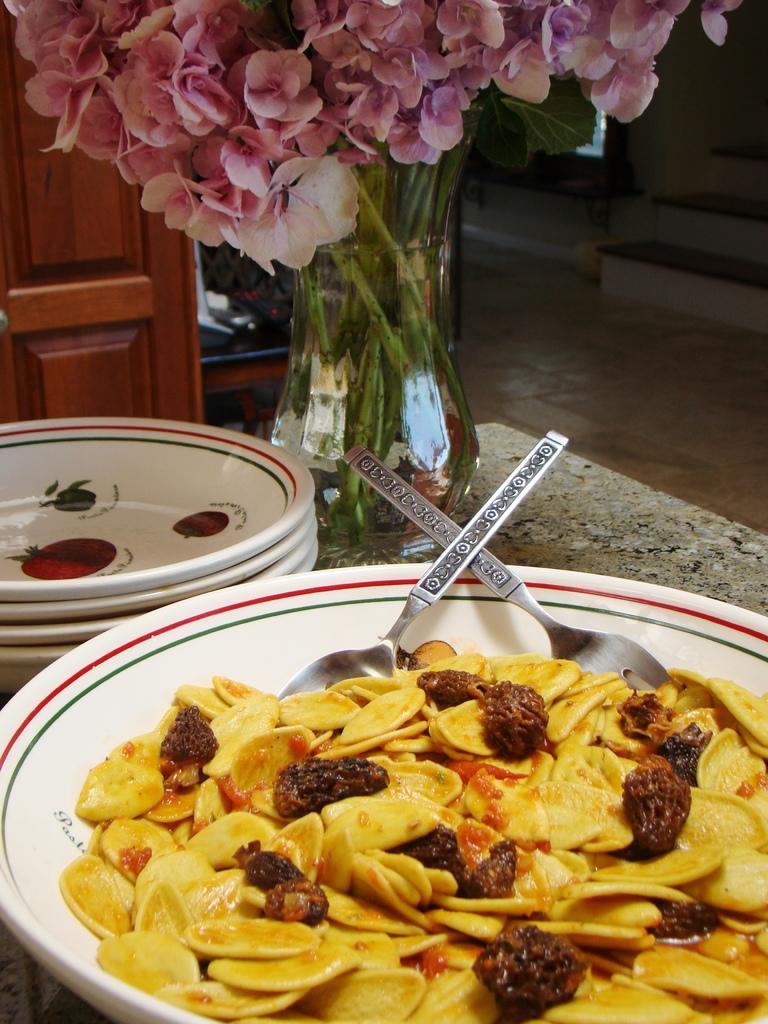Can you describe this image briefly? In this image I can see the food in yellow and brown color in the plate and the plate is in white color. Background I can see few plate, two spoons, a flower pot on some surface and I can see a door in brown color. 